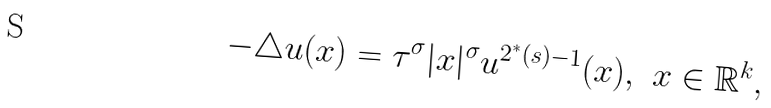<formula> <loc_0><loc_0><loc_500><loc_500>- \triangle u ( x ) = \tau ^ { \sigma } | x | ^ { \sigma } u ^ { 2 ^ { * } ( s ) - 1 } ( x ) , \ x \in \mathbb { R } ^ { k } ,</formula> 